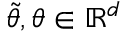<formula> <loc_0><loc_0><loc_500><loc_500>\widetilde { \theta } , \theta \in \mathbb { R } ^ { d }</formula> 